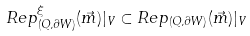<formula> <loc_0><loc_0><loc_500><loc_500>R e p _ { ( Q , \partial W ) } ^ { \xi } ( \vec { m } ) | _ { V } \subset R e p _ { ( Q , \partial W ) } ( \vec { m } ) | _ { V }</formula> 